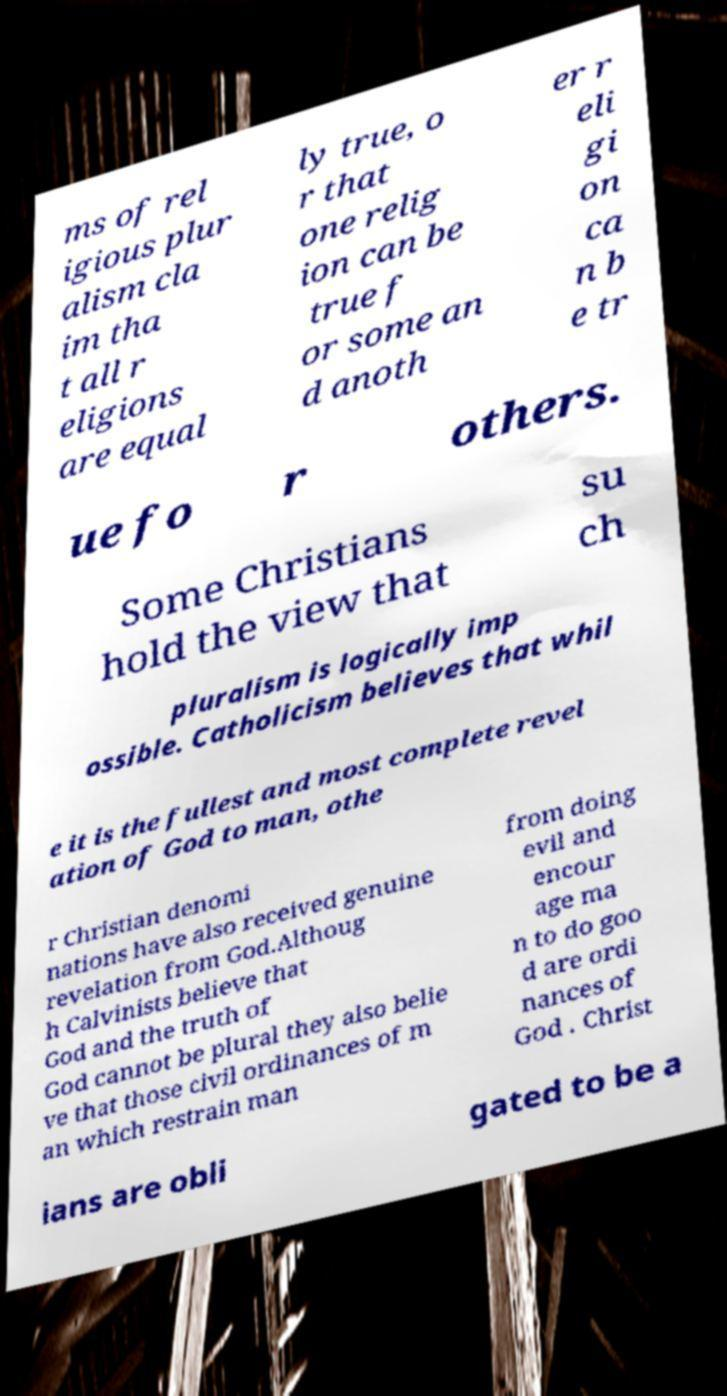Could you extract and type out the text from this image? ms of rel igious plur alism cla im tha t all r eligions are equal ly true, o r that one relig ion can be true f or some an d anoth er r eli gi on ca n b e tr ue fo r others. Some Christians hold the view that su ch pluralism is logically imp ossible. Catholicism believes that whil e it is the fullest and most complete revel ation of God to man, othe r Christian denomi nations have also received genuine revelation from God.Althoug h Calvinists believe that God and the truth of God cannot be plural they also belie ve that those civil ordinances of m an which restrain man from doing evil and encour age ma n to do goo d are ordi nances of God . Christ ians are obli gated to be a 